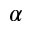Convert formula to latex. <formula><loc_0><loc_0><loc_500><loc_500>\alpha</formula> 